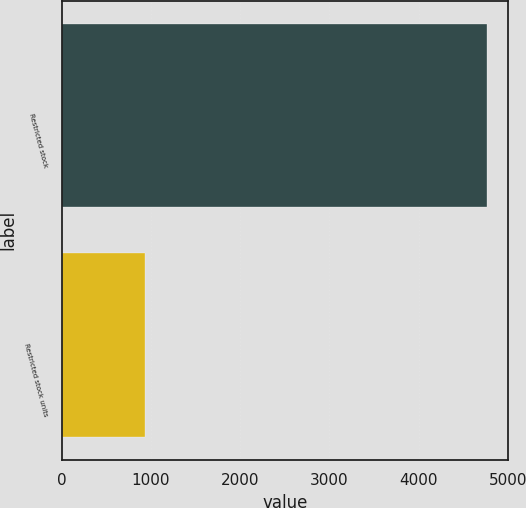<chart> <loc_0><loc_0><loc_500><loc_500><bar_chart><fcel>Restricted stock<fcel>Restricted stock units<nl><fcel>4763<fcel>935<nl></chart> 